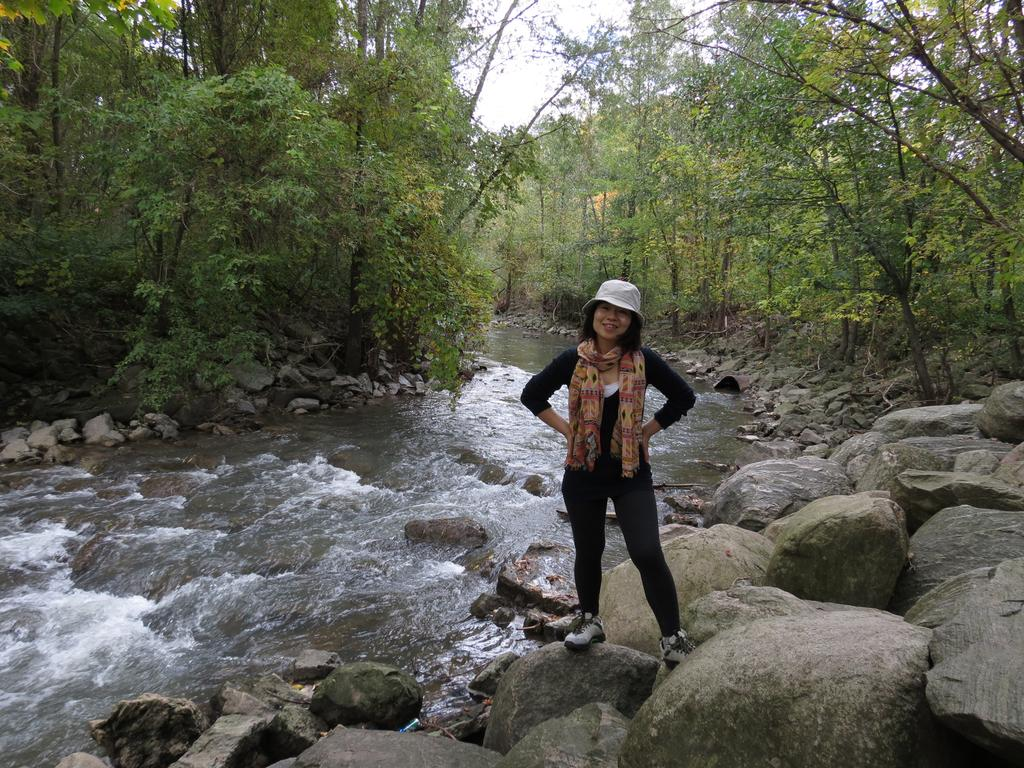What is the main subject of the image? The main subject of the image is a woman. Can you describe the woman's clothing in the image? The woman is wearing a black dress, a scarf, a hat, and shoes. What is the woman standing on in the image? The woman is standing on rocks. What is happening in the background of the image? There is water flowing, trees, and the sky visible in the background of the image. How many men are present in the image? There are no men present in the image; it features a woman. What type of turkey can be seen in the image? There is no turkey present in the image; it features a woman standing on rocks with water flowing in the background. 